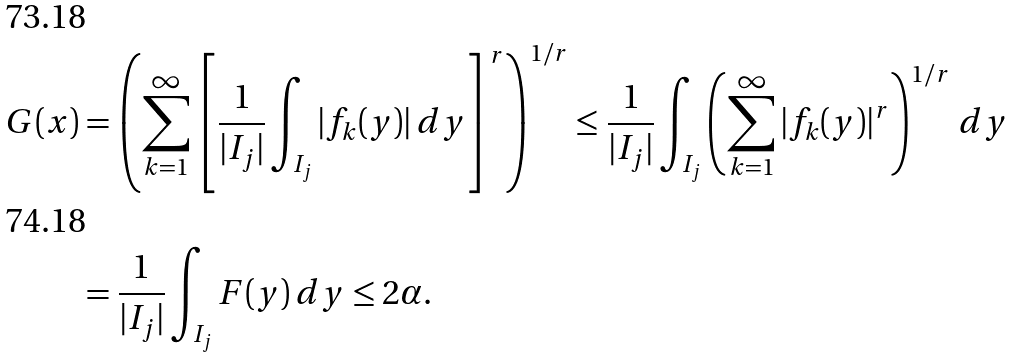Convert formula to latex. <formula><loc_0><loc_0><loc_500><loc_500>G ( x ) & = \left ( \sum _ { k = 1 } ^ { \infty } \left [ \frac { 1 } { | I _ { j } | } \int _ { I _ { j } } | f _ { k } ( y ) | \, d y \right ] ^ { r } \right ) ^ { 1 / r } \leq \frac { 1 } { | I _ { j } | } \int _ { I _ { j } } \left ( \sum _ { k = 1 } ^ { \infty } | f _ { k } ( y ) | ^ { r } \right ) ^ { 1 / r } \, d y \\ & = \frac { 1 } { | I _ { j } | } \int _ { I _ { j } } F ( y ) \, d y \leq 2 \alpha .</formula> 